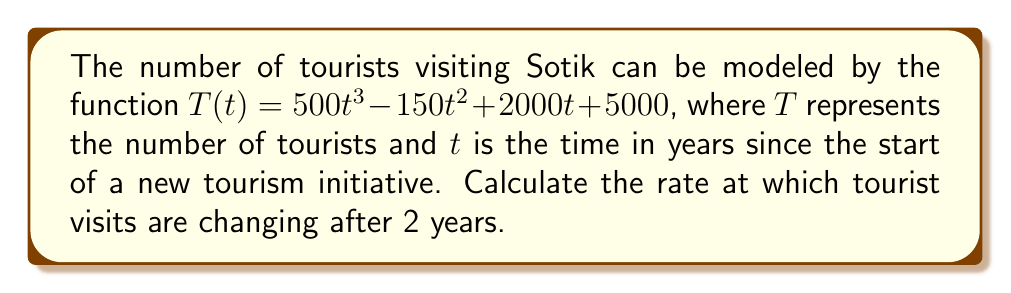Teach me how to tackle this problem. To solve this problem, we need to follow these steps:

1) The rate of change in tourist visits over time is represented by the derivative of the function $T(t)$.

2) Let's find the derivative of $T(t)$:
   
   $T(t) = 500t^3 - 150t^2 + 2000t + 5000$
   
   $T'(t) = 1500t^2 - 300t + 2000$

3) The question asks for the rate of change after 2 years, so we need to evaluate $T'(2)$:

   $T'(2) = 1500(2)^2 - 300(2) + 2000$
   
   $= 1500(4) - 600 + 2000$
   
   $= 6000 - 600 + 2000$
   
   $= 7400$

4) Therefore, after 2 years, the rate of change in tourist visits is 7400 tourists per year.

This positive value indicates that the number of tourists visiting Sotik is increasing at this point in time.
Answer: 7400 tourists per year 